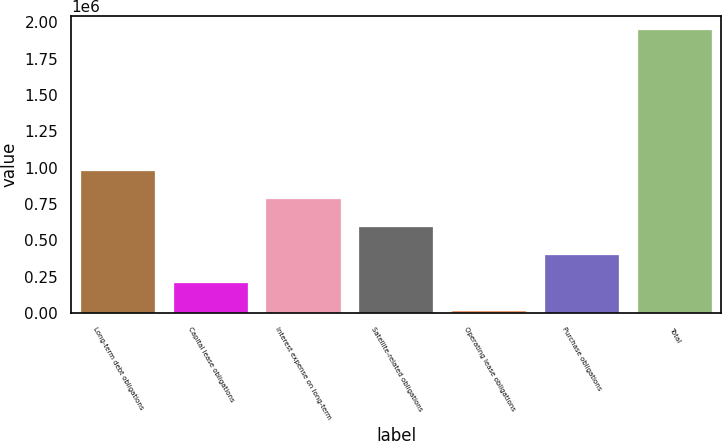Convert chart. <chart><loc_0><loc_0><loc_500><loc_500><bar_chart><fcel>Long-term debt obligations<fcel>Capital lease obligations<fcel>Interest expense on long-term<fcel>Satellite-related obligations<fcel>Operating lease obligations<fcel>Purchase obligations<fcel>Total<nl><fcel>980712<fcel>208262<fcel>787600<fcel>594488<fcel>15150<fcel>401375<fcel>1.94628e+06<nl></chart> 